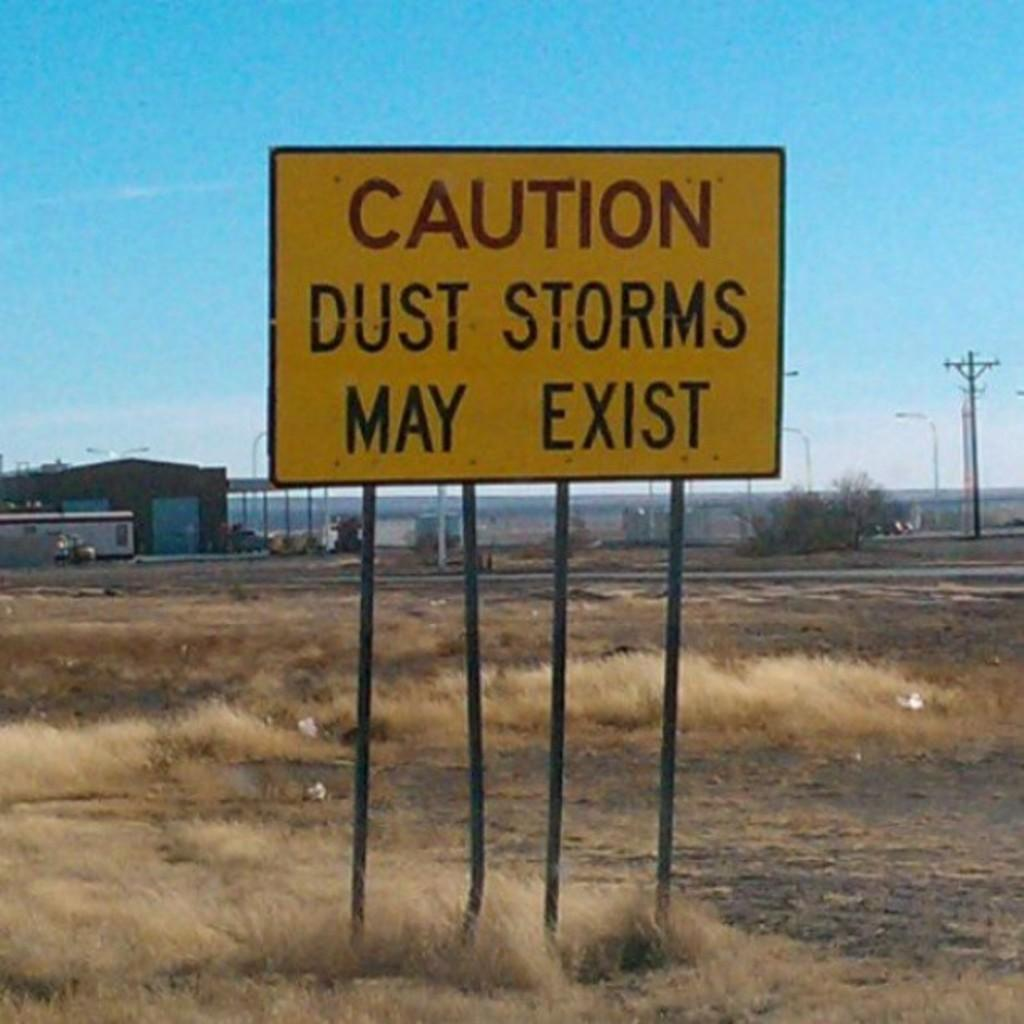Provide a one-sentence caption for the provided image. Roadside sign advising caution because dust storms may exist. 